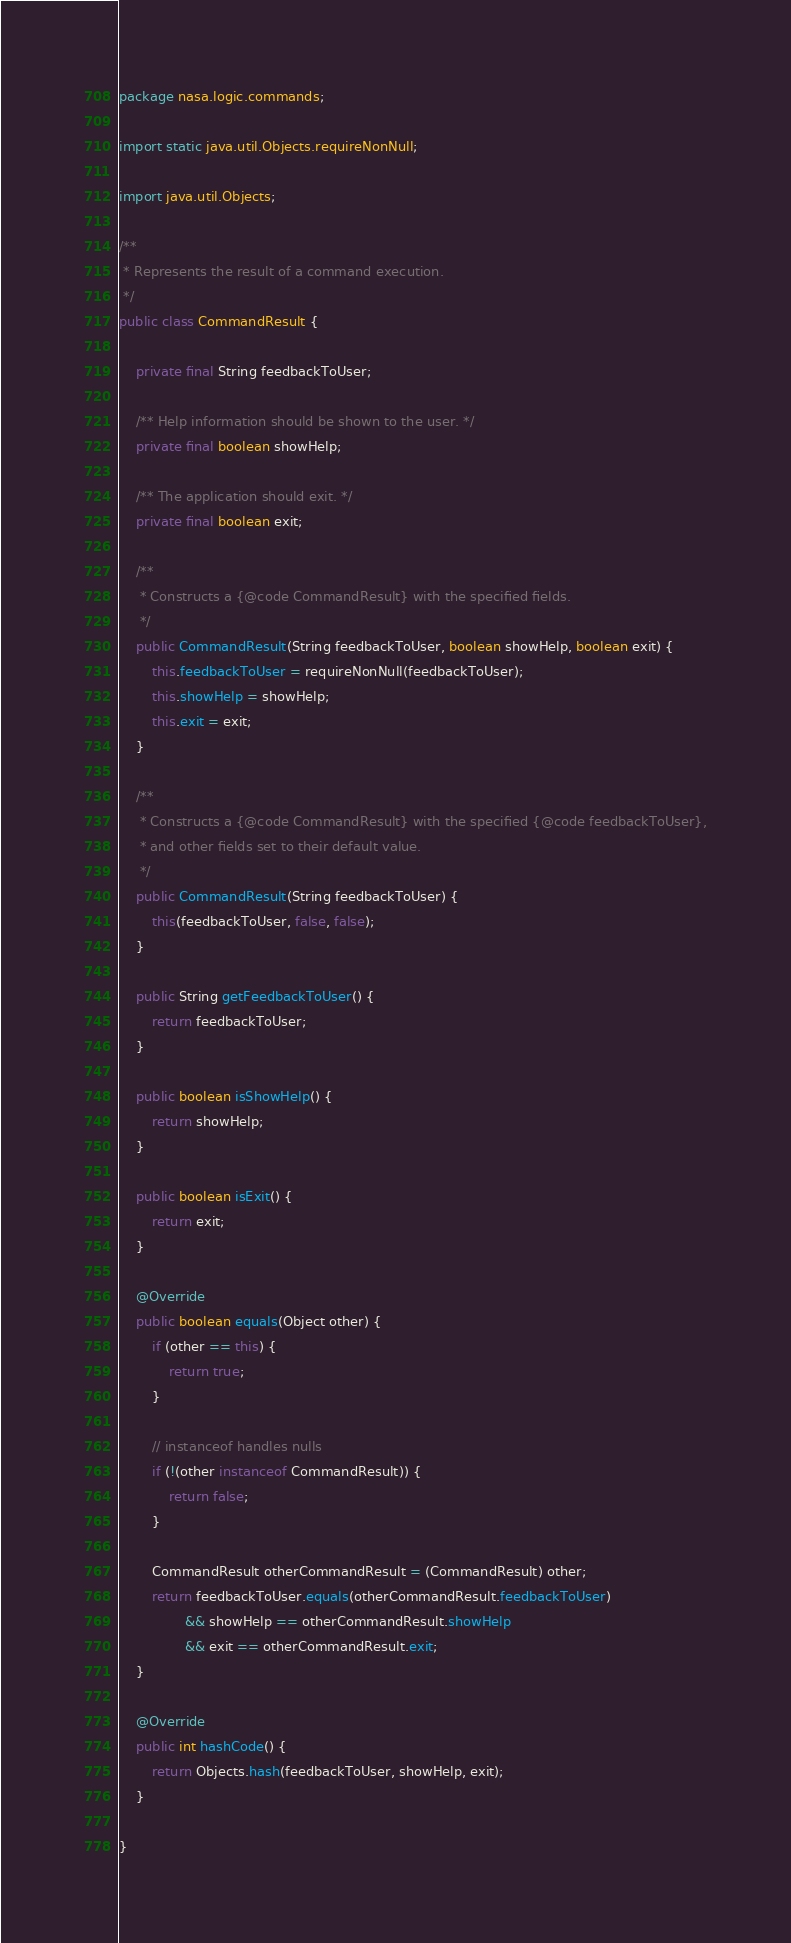<code> <loc_0><loc_0><loc_500><loc_500><_Java_>package nasa.logic.commands;

import static java.util.Objects.requireNonNull;

import java.util.Objects;

/**
 * Represents the result of a command execution.
 */
public class CommandResult {

    private final String feedbackToUser;

    /** Help information should be shown to the user. */
    private final boolean showHelp;

    /** The application should exit. */
    private final boolean exit;

    /**
     * Constructs a {@code CommandResult} with the specified fields.
     */
    public CommandResult(String feedbackToUser, boolean showHelp, boolean exit) {
        this.feedbackToUser = requireNonNull(feedbackToUser);
        this.showHelp = showHelp;
        this.exit = exit;
    }

    /**
     * Constructs a {@code CommandResult} with the specified {@code feedbackToUser},
     * and other fields set to their default value.
     */
    public CommandResult(String feedbackToUser) {
        this(feedbackToUser, false, false);
    }

    public String getFeedbackToUser() {
        return feedbackToUser;
    }

    public boolean isShowHelp() {
        return showHelp;
    }

    public boolean isExit() {
        return exit;
    }

    @Override
    public boolean equals(Object other) {
        if (other == this) {
            return true;
        }

        // instanceof handles nulls
        if (!(other instanceof CommandResult)) {
            return false;
        }

        CommandResult otherCommandResult = (CommandResult) other;
        return feedbackToUser.equals(otherCommandResult.feedbackToUser)
                && showHelp == otherCommandResult.showHelp
                && exit == otherCommandResult.exit;
    }

    @Override
    public int hashCode() {
        return Objects.hash(feedbackToUser, showHelp, exit);
    }

}
</code> 